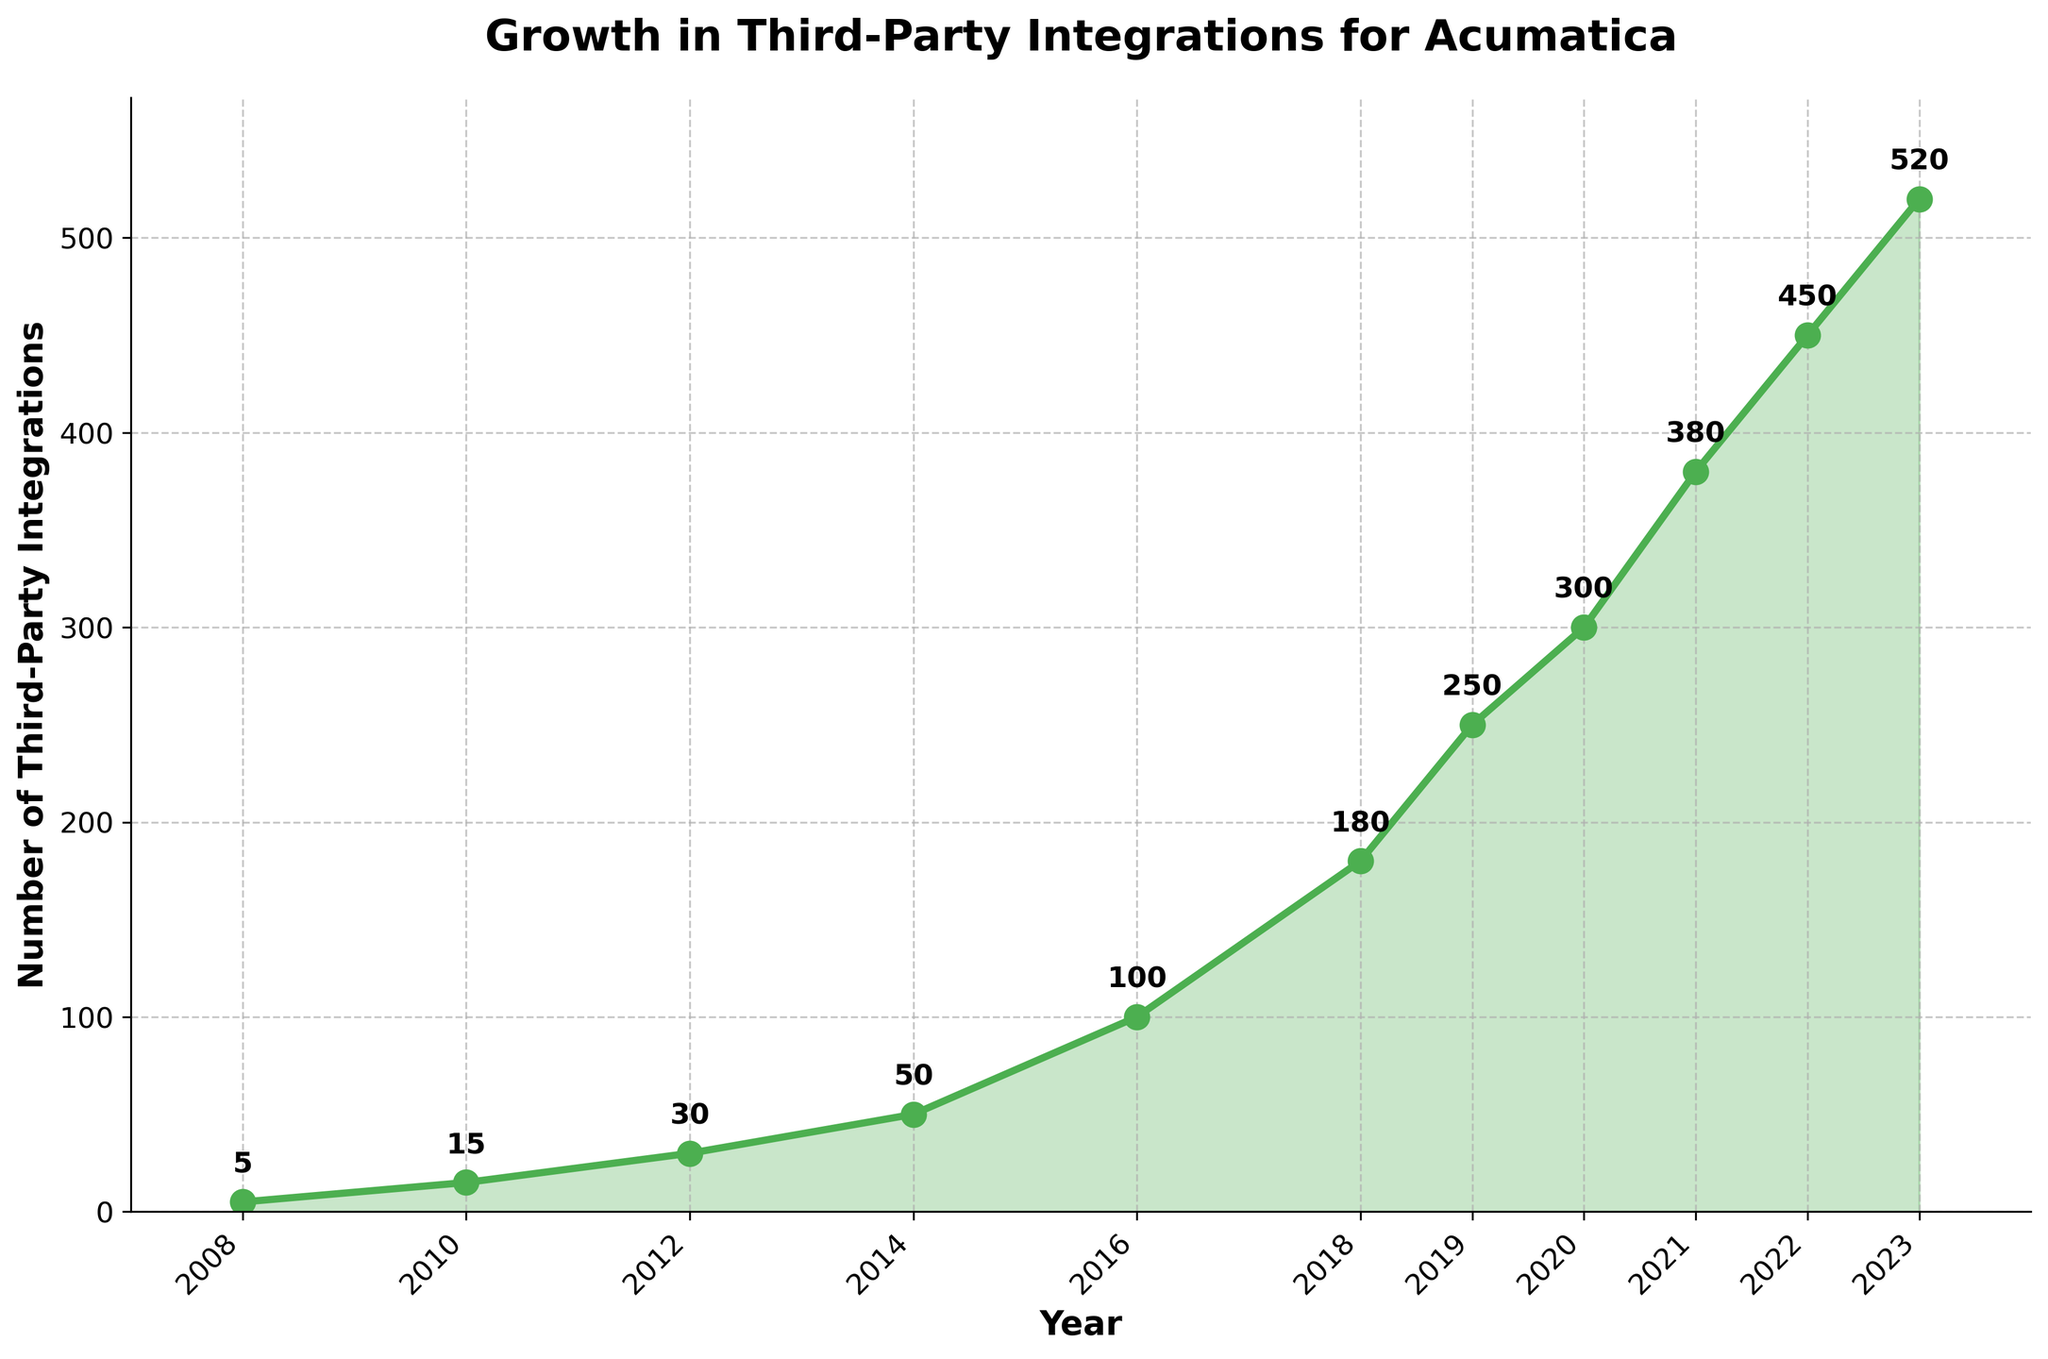What is the total number of third-party integrations available in 2023? To find the total number of third-party integrations in 2023, locate the data point for the year 2023 in the plot. The number associated with that year is 520.
Answer: 520 Between which years did the number of third-party integrations grow the most? To determine the period of most significant growth, compare the differences in integrations between consecutive years shown on the plot. The maximum difference of 80 integrations occurs between 2020 (300) and 2021 (380).
Answer: 2020 and 2021 How many integrations were added from 2014 to 2016? To calculate the difference in the number of integrations between 2014 and 2016, find the values for these years and subtract the earlier year's number from the later year's number: 100 (2016) - 50 (2014) = 50.
Answer: 50 What was the average number of third-party integrations available from 2010 to 2014? To find the average, sum the number of integrations for the years 2010, 2012, and 2014, then divide by the number of data points: (15 + 30 + 50) / 3 = 95 / 3 ≈ 31.67.
Answer: ~31.67 What was the percentage increase in the number of third-party integrations from 2008 to 2023? First, compute the difference between the number of integrations in 2023 and 2008: 520 (2023) - 5 (2008) = 515. Then, calculate the percentage increase: (515 / 5) * 100 ≈ 10300%.
Answer: 10300% Which year marks the midpoint in the visible timeline? The midpoint year between the earliest year (2008) and the latest year (2023) is calculated as ((2023 + 2008) / 2), but since there is no data at the exact midpoint, we identify the closest recorded year. So, (4031 / 2) = 2015.5, closer to 2016.
Answer: 2016 Identify the period with the slowest rate of growth. To find the period with the slowest rate of growth, identify the smallest increase between consecutive years on the plot. The slowest growth occurs between 2010 (15) and 2012 (30), with an increase of 15.
Answer: 2010 to 2012 Is the rate of growth of third-party integrations accelerating, decelerating, or stable? By visually inspecting the slope of the line on the plot, it is apparent that the rate of growth is accelerating since the slope becomes steeper over time.
Answer: Accelerating What is the cumulative number of third-party integrations by 2016? Sum the number of integrations provided for each year leading up to and including 2016: 5 (2008) + 15 (2010) + 30 (2012) + 50 (2014) + 100 (2016) = 200.
Answer: 200 How does the number of integrations in 2019 compare to 2011? Locate the number of integrations for 2019 and 2011. 2019 has 250, while 2011 falls between 2010 (15) and 2012 (30), so we use interpolation ((15 + 30) / 2 = 22.5). The number in 2019 (250) is significantly higher.
Answer: 2019 has more integrations than 2011 